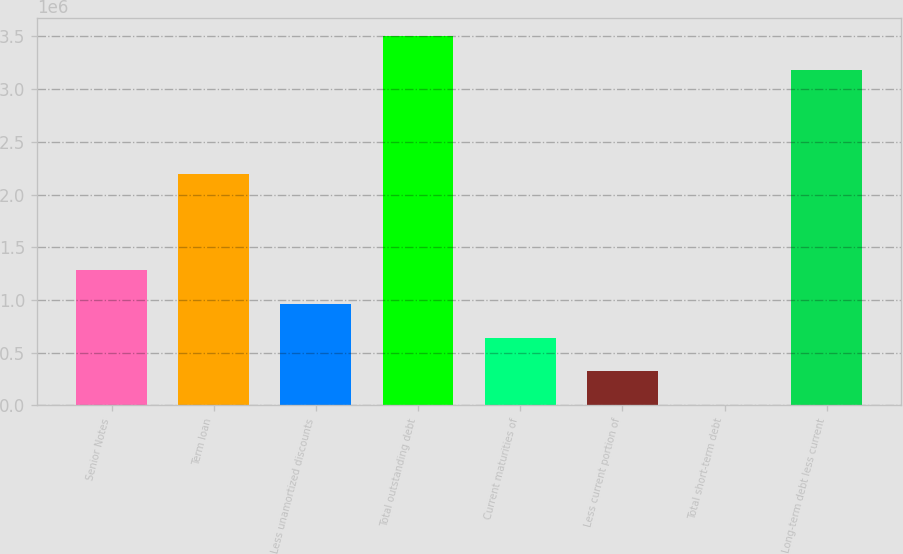Convert chart to OTSL. <chart><loc_0><loc_0><loc_500><loc_500><bar_chart><fcel>Senior Notes<fcel>Term loan<fcel>Less unamortized discounts<fcel>Total outstanding debt<fcel>Current maturities of<fcel>Less current portion of<fcel>Total short-term debt<fcel>Long-term debt less current<nl><fcel>1.28071e+06<fcel>2.2e+06<fcel>962411<fcel>3.50126e+06<fcel>644114<fcel>325818<fcel>7522<fcel>3.18296e+06<nl></chart> 